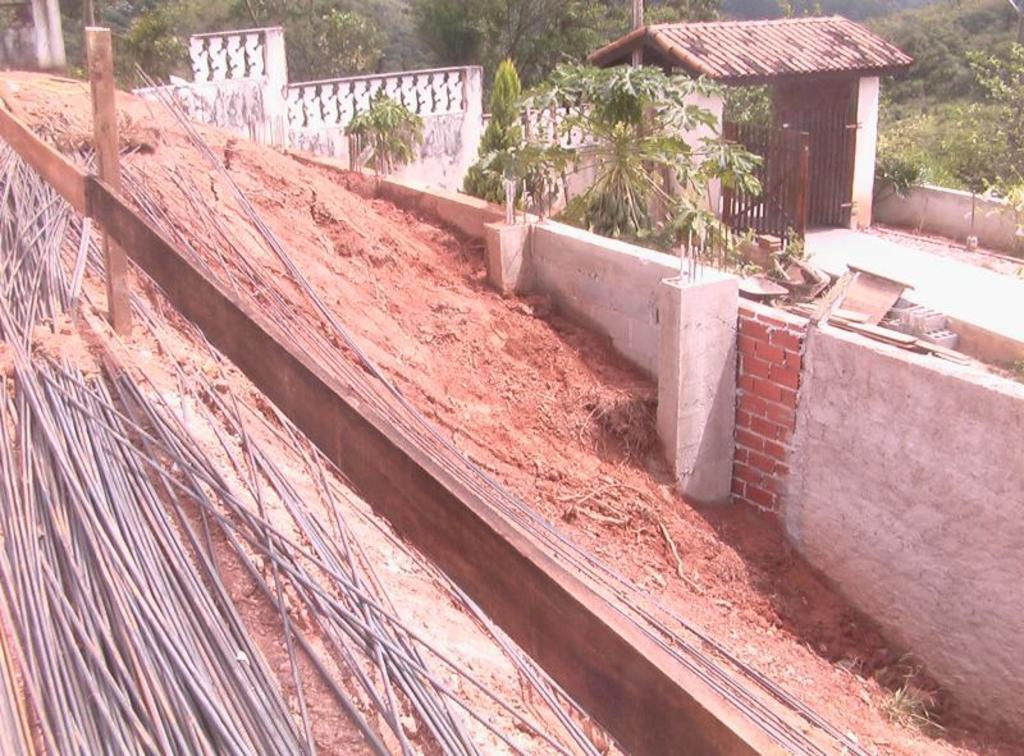What objects are placed beside the wooden fence in the image? There are metal rods placed beside the wooden fence in the image. What type of vegetation can be seen in the image? There are plants visible in the image. Can you describe the main structure in the image? There is a house with a roof in the image. What type of barrier is present in the image? There is a fence in the image. What type of terrain is visible in the image? There is mud visible in the image. How many trees are grouped together in the image? There is a group of trees in the image. What type of punishment is being administered to the sticks in the image? There are no sticks present in the image, nor is any punishment being administered. Who are the friends seen interacting with each other in the image? There is no reference to friends or any social interaction in the image. 